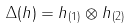<formula> <loc_0><loc_0><loc_500><loc_500>\Delta ( h ) = h _ { ( 1 ) } \otimes h _ { ( 2 ) }</formula> 